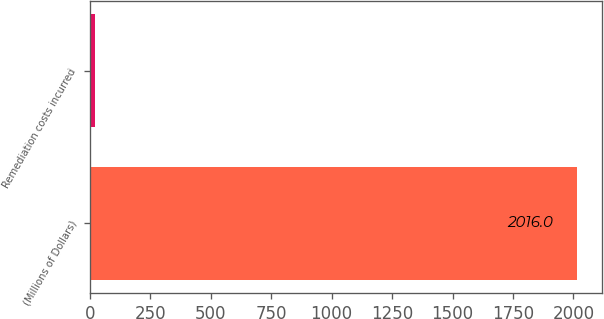Convert chart to OTSL. <chart><loc_0><loc_0><loc_500><loc_500><bar_chart><fcel>(Millions of Dollars)<fcel>Remediation costs incurred<nl><fcel>2016<fcel>21<nl></chart> 